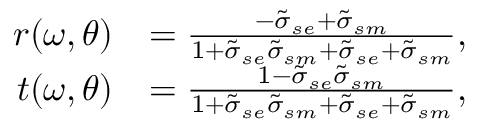<formula> <loc_0><loc_0><loc_500><loc_500>\begin{array} { r l } { r ( \omega , \theta ) } & { = \frac { - \tilde { \sigma } _ { s e } + \tilde { \sigma } _ { s m } } { 1 + \tilde { \sigma } _ { s e } \tilde { \sigma } _ { s m } + \tilde { \sigma } _ { s e } + \tilde { \sigma } _ { s m } } , } \\ { t ( \omega , \theta ) } & { = \frac { 1 - \tilde { \sigma } _ { s e } \tilde { \sigma } _ { s m } } { 1 + \tilde { \sigma } _ { s e } \tilde { \sigma } _ { s m } + \tilde { \sigma } _ { s e } + \tilde { \sigma } _ { s m } } , } \end{array}</formula> 